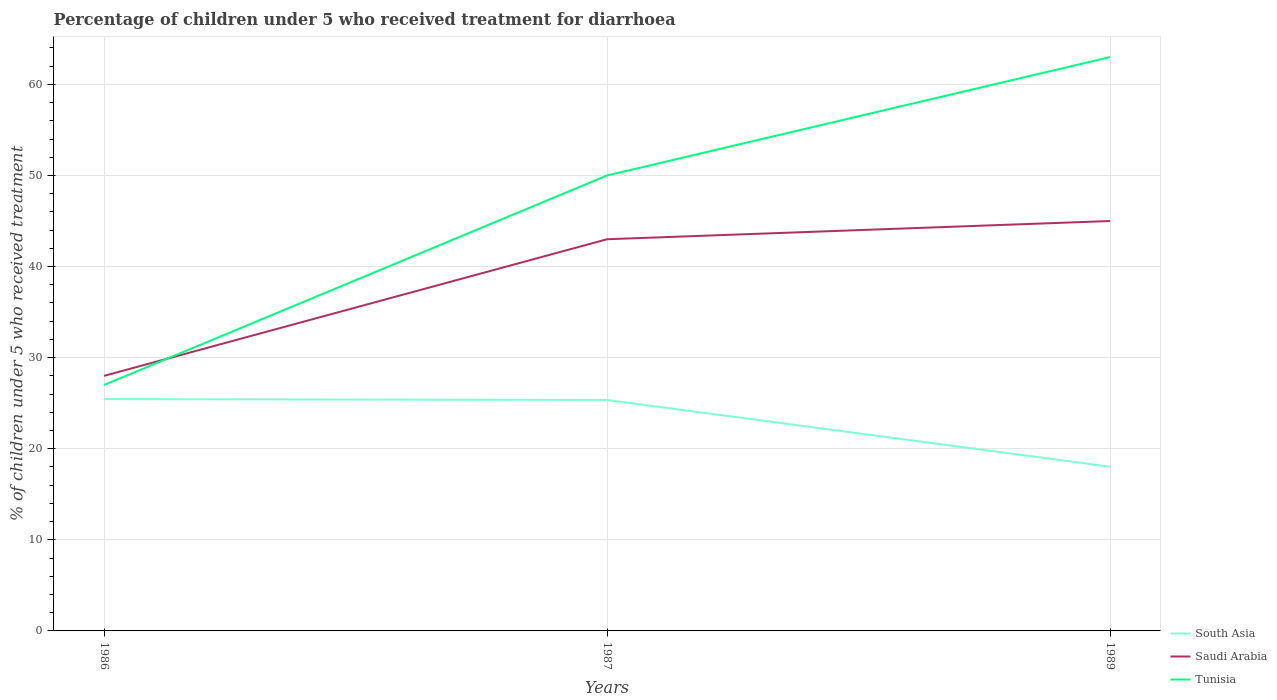How many different coloured lines are there?
Provide a succinct answer. 3. Does the line corresponding to South Asia intersect with the line corresponding to Saudi Arabia?
Provide a short and direct response. No. Across all years, what is the maximum percentage of children who received treatment for diarrhoea  in Saudi Arabia?
Ensure brevity in your answer.  28. In which year was the percentage of children who received treatment for diarrhoea  in Tunisia maximum?
Keep it short and to the point. 1986. What is the difference between the highest and the second highest percentage of children who received treatment for diarrhoea  in South Asia?
Ensure brevity in your answer.  7.42. What is the difference between the highest and the lowest percentage of children who received treatment for diarrhoea  in Saudi Arabia?
Keep it short and to the point. 2. Is the percentage of children who received treatment for diarrhoea  in Tunisia strictly greater than the percentage of children who received treatment for diarrhoea  in South Asia over the years?
Offer a terse response. No. How many lines are there?
Provide a short and direct response. 3. Are the values on the major ticks of Y-axis written in scientific E-notation?
Your response must be concise. No. Does the graph contain any zero values?
Provide a succinct answer. No. Does the graph contain grids?
Give a very brief answer. Yes. What is the title of the graph?
Ensure brevity in your answer.  Percentage of children under 5 who received treatment for diarrhoea. Does "Aruba" appear as one of the legend labels in the graph?
Keep it short and to the point. No. What is the label or title of the X-axis?
Provide a succinct answer. Years. What is the label or title of the Y-axis?
Make the answer very short. % of children under 5 who received treatment. What is the % of children under 5 who received treatment in South Asia in 1986?
Provide a succinct answer. 25.45. What is the % of children under 5 who received treatment in South Asia in 1987?
Provide a succinct answer. 25.35. What is the % of children under 5 who received treatment in South Asia in 1989?
Provide a short and direct response. 18.03. What is the % of children under 5 who received treatment of Tunisia in 1989?
Provide a succinct answer. 63. Across all years, what is the maximum % of children under 5 who received treatment in South Asia?
Provide a short and direct response. 25.45. Across all years, what is the maximum % of children under 5 who received treatment in Saudi Arabia?
Give a very brief answer. 45. Across all years, what is the maximum % of children under 5 who received treatment in Tunisia?
Provide a short and direct response. 63. Across all years, what is the minimum % of children under 5 who received treatment in South Asia?
Your answer should be very brief. 18.03. Across all years, what is the minimum % of children under 5 who received treatment of Tunisia?
Your response must be concise. 27. What is the total % of children under 5 who received treatment in South Asia in the graph?
Offer a very short reply. 68.83. What is the total % of children under 5 who received treatment of Saudi Arabia in the graph?
Your response must be concise. 116. What is the total % of children under 5 who received treatment of Tunisia in the graph?
Provide a short and direct response. 140. What is the difference between the % of children under 5 who received treatment of South Asia in 1986 and that in 1987?
Offer a terse response. 0.1. What is the difference between the % of children under 5 who received treatment in Tunisia in 1986 and that in 1987?
Offer a terse response. -23. What is the difference between the % of children under 5 who received treatment in South Asia in 1986 and that in 1989?
Keep it short and to the point. 7.42. What is the difference between the % of children under 5 who received treatment in Tunisia in 1986 and that in 1989?
Your response must be concise. -36. What is the difference between the % of children under 5 who received treatment in South Asia in 1987 and that in 1989?
Ensure brevity in your answer.  7.32. What is the difference between the % of children under 5 who received treatment of Saudi Arabia in 1987 and that in 1989?
Keep it short and to the point. -2. What is the difference between the % of children under 5 who received treatment in Tunisia in 1987 and that in 1989?
Provide a short and direct response. -13. What is the difference between the % of children under 5 who received treatment in South Asia in 1986 and the % of children under 5 who received treatment in Saudi Arabia in 1987?
Keep it short and to the point. -17.55. What is the difference between the % of children under 5 who received treatment in South Asia in 1986 and the % of children under 5 who received treatment in Tunisia in 1987?
Your response must be concise. -24.55. What is the difference between the % of children under 5 who received treatment of Saudi Arabia in 1986 and the % of children under 5 who received treatment of Tunisia in 1987?
Ensure brevity in your answer.  -22. What is the difference between the % of children under 5 who received treatment of South Asia in 1986 and the % of children under 5 who received treatment of Saudi Arabia in 1989?
Keep it short and to the point. -19.55. What is the difference between the % of children under 5 who received treatment in South Asia in 1986 and the % of children under 5 who received treatment in Tunisia in 1989?
Your answer should be very brief. -37.55. What is the difference between the % of children under 5 who received treatment of Saudi Arabia in 1986 and the % of children under 5 who received treatment of Tunisia in 1989?
Keep it short and to the point. -35. What is the difference between the % of children under 5 who received treatment of South Asia in 1987 and the % of children under 5 who received treatment of Saudi Arabia in 1989?
Your response must be concise. -19.65. What is the difference between the % of children under 5 who received treatment of South Asia in 1987 and the % of children under 5 who received treatment of Tunisia in 1989?
Offer a very short reply. -37.65. What is the difference between the % of children under 5 who received treatment of Saudi Arabia in 1987 and the % of children under 5 who received treatment of Tunisia in 1989?
Your answer should be very brief. -20. What is the average % of children under 5 who received treatment of South Asia per year?
Give a very brief answer. 22.94. What is the average % of children under 5 who received treatment in Saudi Arabia per year?
Ensure brevity in your answer.  38.67. What is the average % of children under 5 who received treatment in Tunisia per year?
Ensure brevity in your answer.  46.67. In the year 1986, what is the difference between the % of children under 5 who received treatment in South Asia and % of children under 5 who received treatment in Saudi Arabia?
Make the answer very short. -2.55. In the year 1986, what is the difference between the % of children under 5 who received treatment in South Asia and % of children under 5 who received treatment in Tunisia?
Your answer should be very brief. -1.55. In the year 1986, what is the difference between the % of children under 5 who received treatment of Saudi Arabia and % of children under 5 who received treatment of Tunisia?
Keep it short and to the point. 1. In the year 1987, what is the difference between the % of children under 5 who received treatment of South Asia and % of children under 5 who received treatment of Saudi Arabia?
Offer a very short reply. -17.65. In the year 1987, what is the difference between the % of children under 5 who received treatment in South Asia and % of children under 5 who received treatment in Tunisia?
Ensure brevity in your answer.  -24.65. In the year 1987, what is the difference between the % of children under 5 who received treatment in Saudi Arabia and % of children under 5 who received treatment in Tunisia?
Ensure brevity in your answer.  -7. In the year 1989, what is the difference between the % of children under 5 who received treatment in South Asia and % of children under 5 who received treatment in Saudi Arabia?
Your response must be concise. -26.97. In the year 1989, what is the difference between the % of children under 5 who received treatment of South Asia and % of children under 5 who received treatment of Tunisia?
Give a very brief answer. -44.97. What is the ratio of the % of children under 5 who received treatment in South Asia in 1986 to that in 1987?
Your answer should be compact. 1. What is the ratio of the % of children under 5 who received treatment in Saudi Arabia in 1986 to that in 1987?
Keep it short and to the point. 0.65. What is the ratio of the % of children under 5 who received treatment of Tunisia in 1986 to that in 1987?
Your answer should be compact. 0.54. What is the ratio of the % of children under 5 who received treatment in South Asia in 1986 to that in 1989?
Your answer should be very brief. 1.41. What is the ratio of the % of children under 5 who received treatment of Saudi Arabia in 1986 to that in 1989?
Ensure brevity in your answer.  0.62. What is the ratio of the % of children under 5 who received treatment in Tunisia in 1986 to that in 1989?
Offer a terse response. 0.43. What is the ratio of the % of children under 5 who received treatment in South Asia in 1987 to that in 1989?
Offer a very short reply. 1.41. What is the ratio of the % of children under 5 who received treatment in Saudi Arabia in 1987 to that in 1989?
Provide a short and direct response. 0.96. What is the ratio of the % of children under 5 who received treatment in Tunisia in 1987 to that in 1989?
Offer a very short reply. 0.79. What is the difference between the highest and the second highest % of children under 5 who received treatment of South Asia?
Your answer should be compact. 0.1. What is the difference between the highest and the second highest % of children under 5 who received treatment of Tunisia?
Provide a short and direct response. 13. What is the difference between the highest and the lowest % of children under 5 who received treatment in South Asia?
Ensure brevity in your answer.  7.42. 